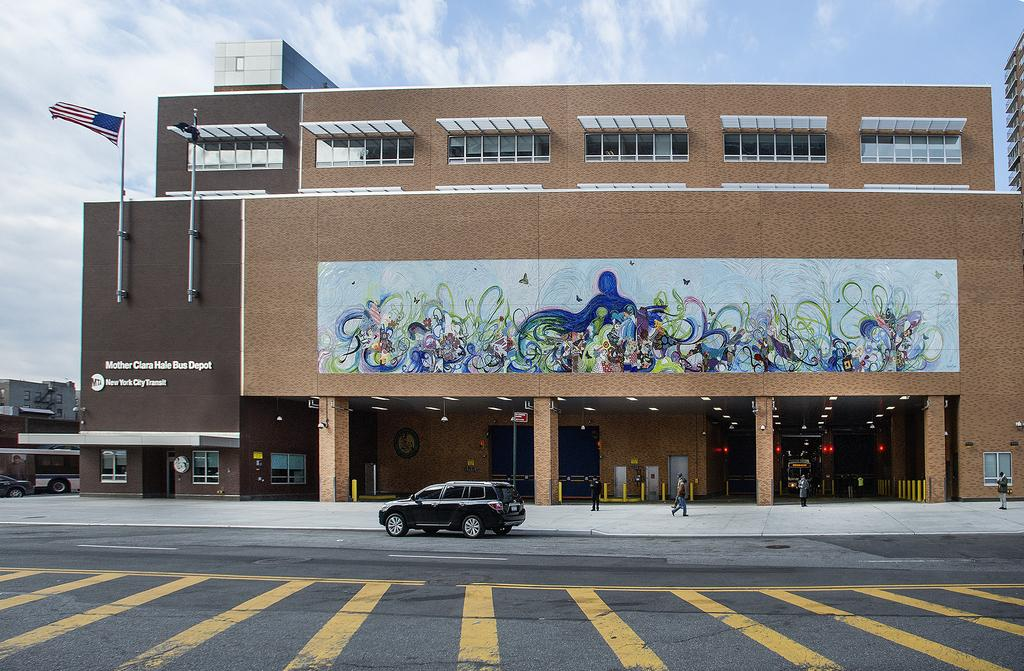What is the main subject of the image? The main subject of the image is a car. Where is the car located in the image? The car is on a road in the image. What color is the car? The car is black. What else can be seen in the image besides the car? There is a big building in the image. What is the weather like in the image? The sky is sunny in the image. What is the opinion of the car in the image? The image does not express an opinion about the car; it simply shows the car on a road. How much money is being exchanged in the image? There is no indication of money being exchanged in the image; it only features a car on a road and a big building. 